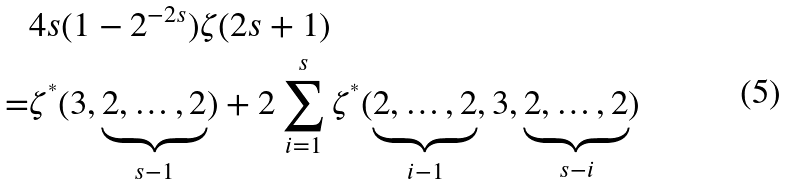<formula> <loc_0><loc_0><loc_500><loc_500>& 4 s ( 1 - 2 ^ { - 2 s } ) \zeta ( 2 s + 1 ) \\ = & \zeta ^ { ^ { * } } ( 3 , \underbrace { 2 , \dots , 2 } _ { s - 1 } ) + 2 \sum _ { i = 1 } ^ { s } \zeta ^ { ^ { * } } ( \underbrace { 2 , \dots , 2 } _ { i - 1 } , 3 , \underbrace { 2 , \dots , 2 } _ { s - i } )</formula> 